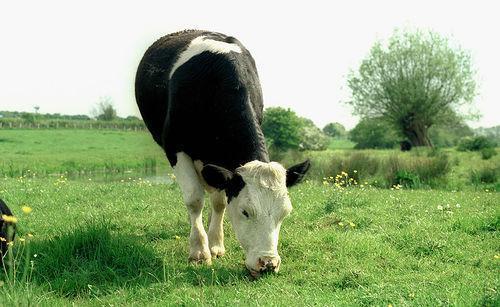How many cows are there?
Give a very brief answer. 1. 